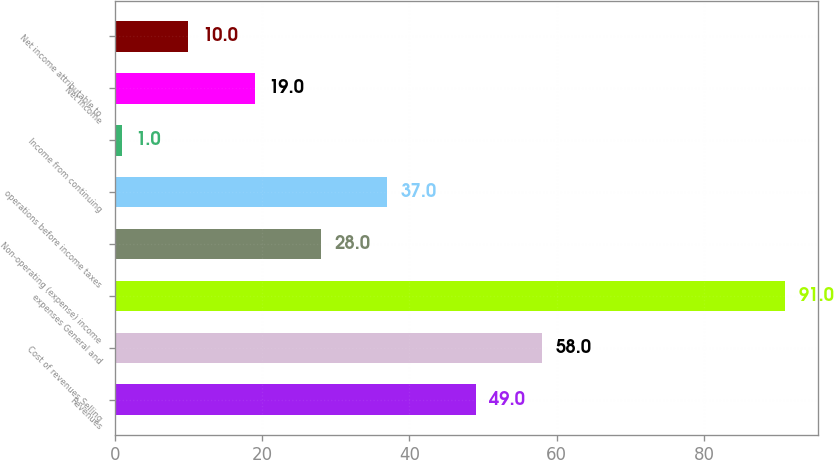Convert chart to OTSL. <chart><loc_0><loc_0><loc_500><loc_500><bar_chart><fcel>Revenues<fcel>Cost of revenues Selling<fcel>expenses General and<fcel>Non-operating (expense) income<fcel>operations before income taxes<fcel>Income from continuing<fcel>Net income<fcel>Net income attributable to<nl><fcel>49<fcel>58<fcel>91<fcel>28<fcel>37<fcel>1<fcel>19<fcel>10<nl></chart> 